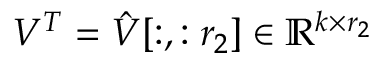<formula> <loc_0><loc_0><loc_500><loc_500>V ^ { T } = \hat { V } [ \colon , \colon r _ { 2 } ] \in \mathbb { R } ^ { k \times r _ { 2 } }</formula> 